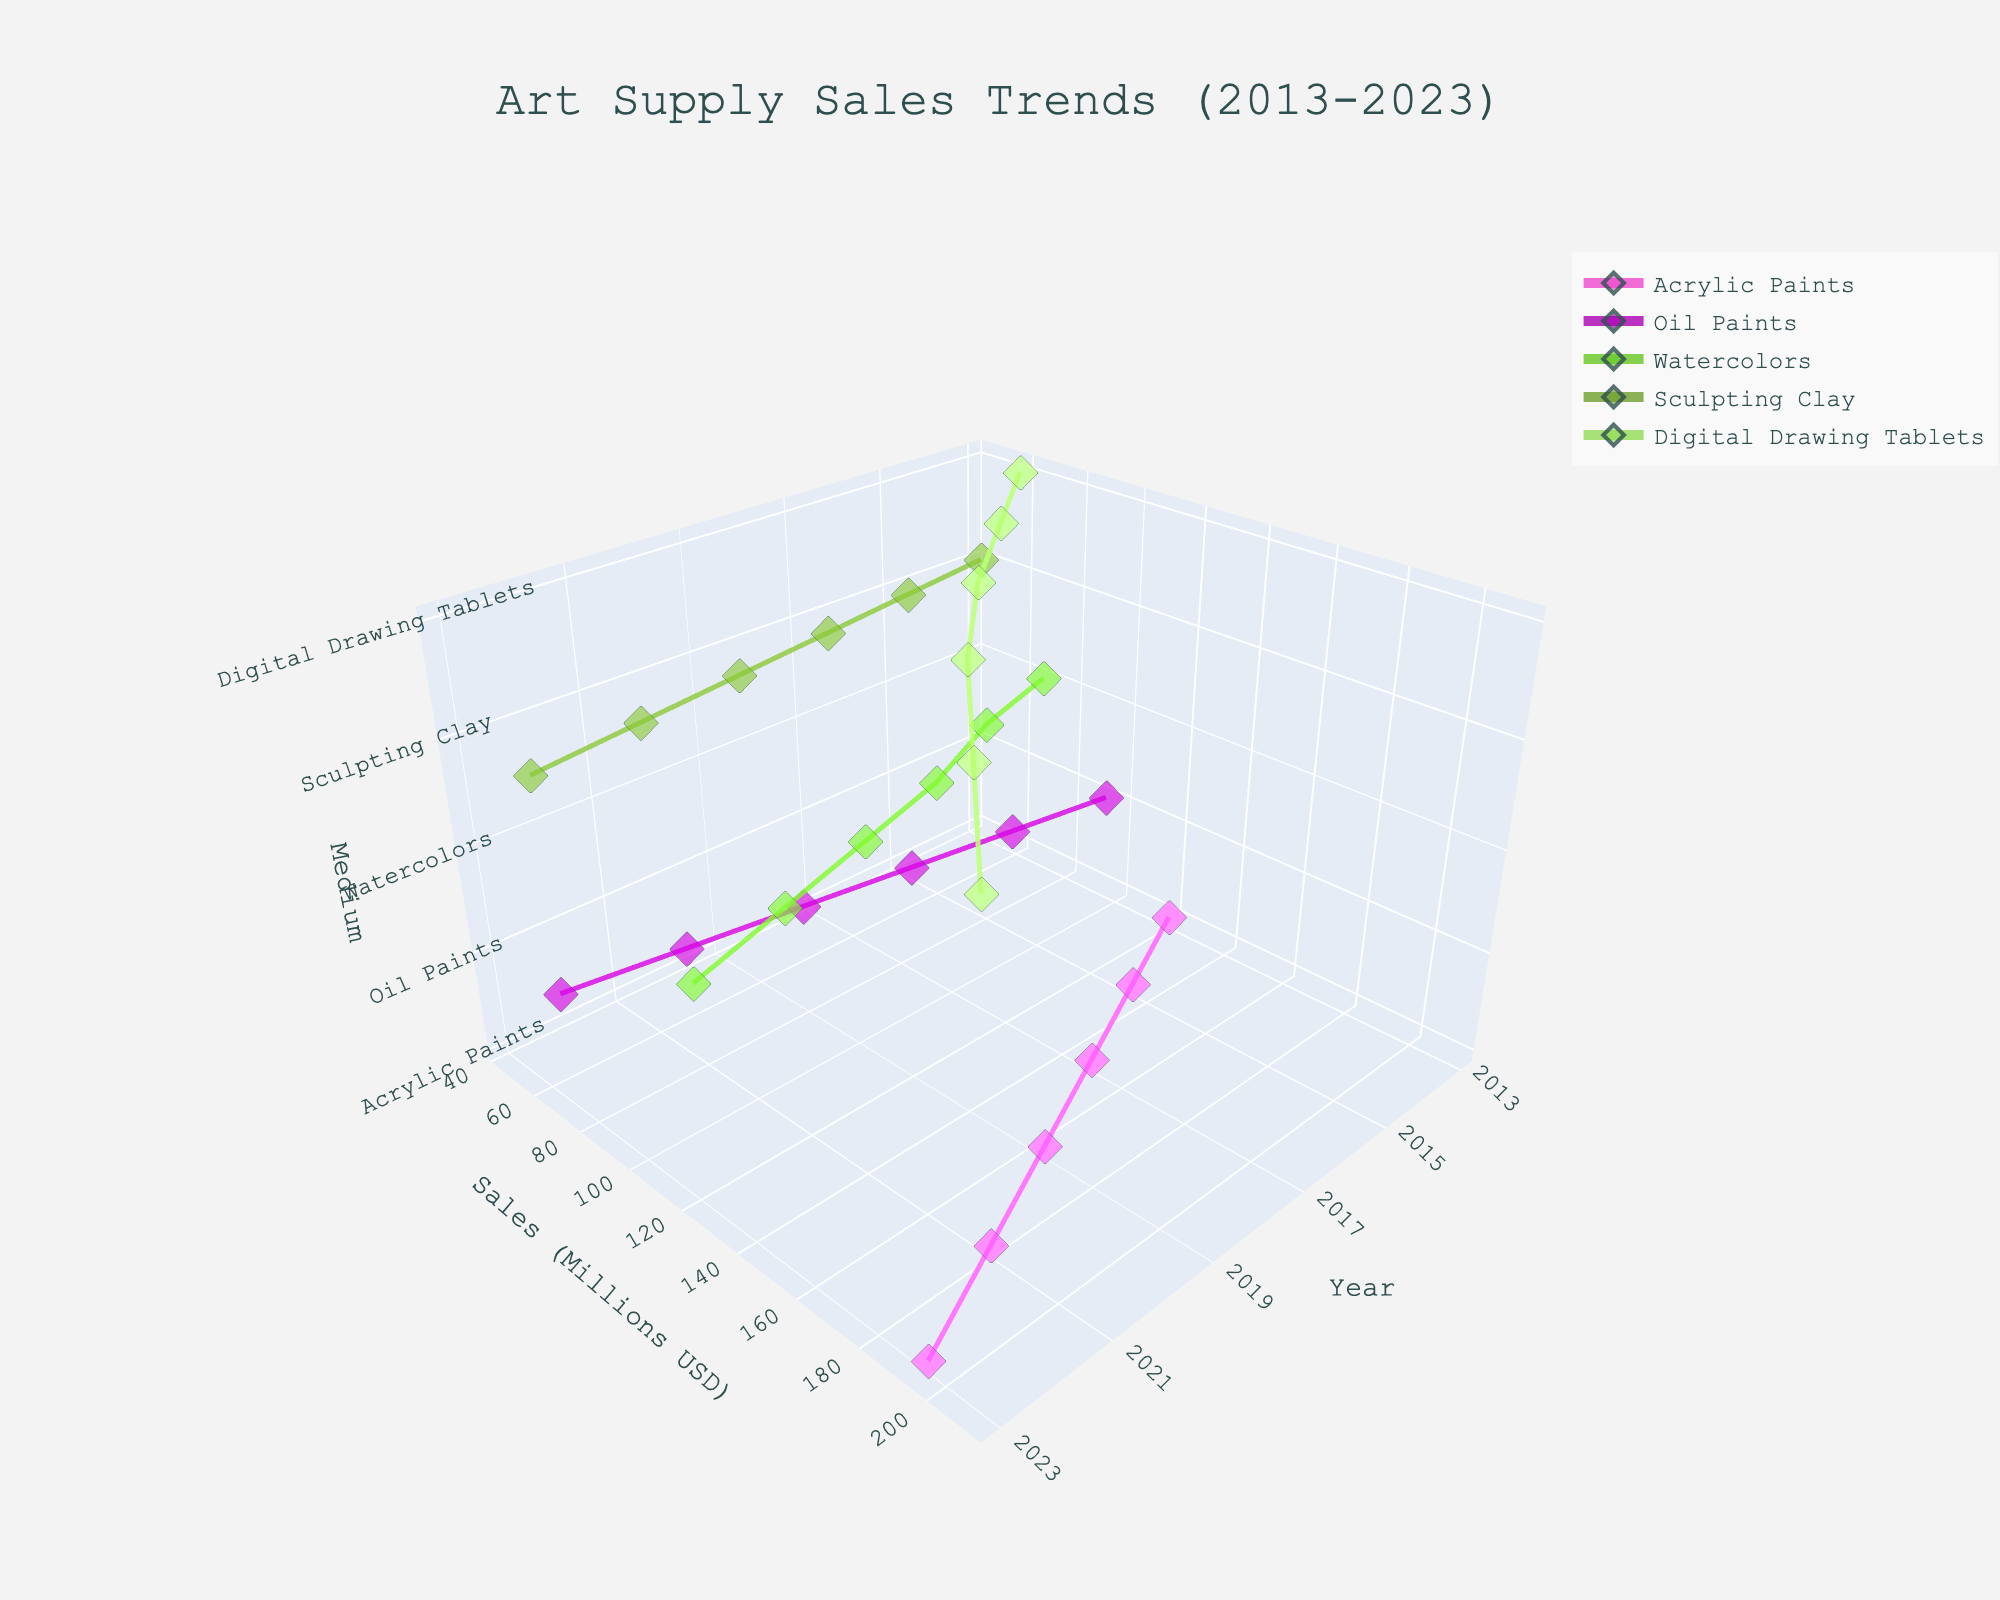What is the title of the figure? The title of the figure is prominently displayed at the top. It states "Art Supply Sales Trends (2013-2023)."
Answer: Art Supply Sales Trends (2013-2023) How many different types of art supplies are included in the plot? There are markers representing different art supplies, with 5 types evident: Acrylic Paints, Oil Paints, Watercolors, Sculpting Clay, and Digital Drawing Tablets.
Answer: 5 Which medium had the highest sales in 2023? To determine the highest sales in 2023, look at the markers corresponding to 2023 and compare the highest value on the sales axis. The medium with the highest sales is Digital Drawing Tablets.
Answer: Digital Drawing Tablets How did sales of Sculpting Clay change from 2013 to 2023? Identify the points for Sculpting Clay at 2013 and 2023 on the graph and note their sales. In 2013, sales were 45 million USD, and in 2023 they were 70 million USD. There was an increase in sales.
Answer: Increased What's the trend observed in sales for Digital Drawing Tablets over the decade? Trace the markers for Digital Drawing Tablets across all the years. Sales show a consistent increasing trend from 60 million USD in 2013 to 210 million USD in 2023.
Answer: Increasing By how much did the sales of Acrylic Paints increase from 2013 to 2023? Locate the sales figures for Acrylic Paints in 2013 and 2023. Sales in 2013 were 120 million USD, and in 2023 they were 195 million USD. The increase is 195 - 120 = 75 million USD.
Answer: 75 million USD Compare the sales of Oil Paints and Watercolors in 2019. Which was higher? Locate the sales figures for Oil Paints and Watercolors in 2019. Oil Paints had sales of 80 million USD, and Watercolors had sales of 105 million USD. Watercolors had higher sales.
Answer: Watercolors Which medium had the lowest sales in 2015? Identify the markers for all mediums in 2015 and find the lowest sales value. Sculpting Clay had the lowest sales with 50 million USD.
Answer: Sculpting Clay What's the total sales for all mediums combined in 2021? Sum the sales for each medium in 2021: Acrylic Paints (180), Oil Paints (75), Watercolors (115), Sculpting Clay (65), Digital Drawing Tablets (175). Total = 180 + 75 + 115 + 65 + 175 = 610 million USD.
Answer: 610 million USD What's the average sales value of Watercolors from 2013 to 2023? Identify the sales figures for Watercolors: 2013 (70), 2015 (80), 2017 (95), 2019 (105), 2021 (115), 2023 (125). Sum these values and divide by the number of years: (70 + 80 + 95 + 105 + 115 + 125)/6 ≈ 98.33 million USD.
Answer: ≈ 98.33 million USD 